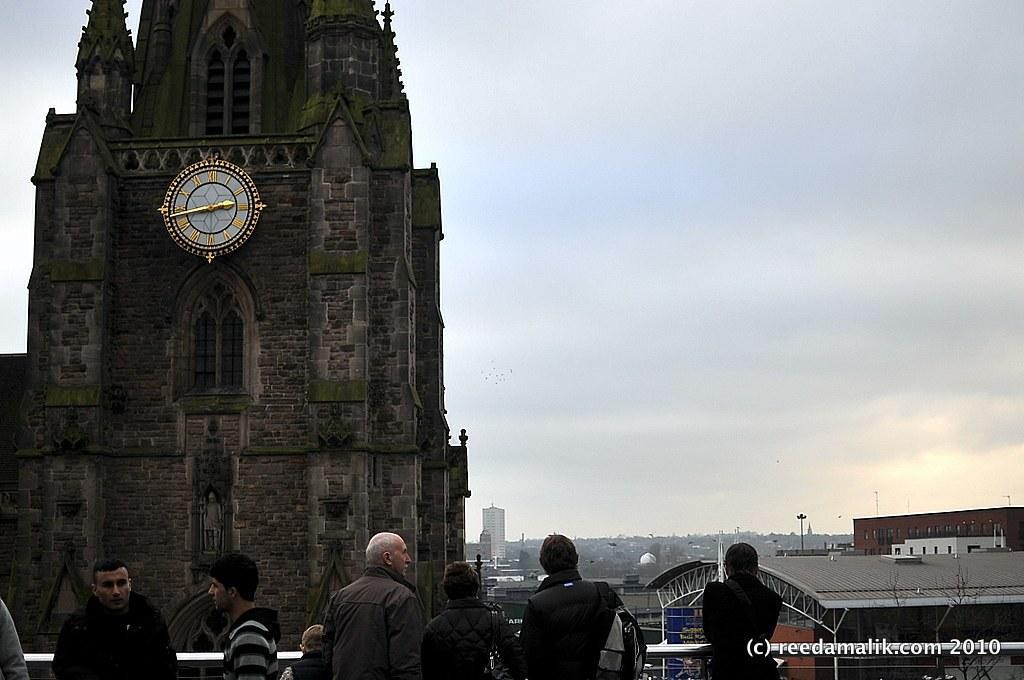Who or what can be seen in the image? There are people in the image. What type of structures are visible in the image? There are buildings in the image. Can you describe any specific objects in the image? There is a wall clock in the image. What else can be seen in the image? There are poles in the image. What is visible in the background of the image? The sky is visible in the image. Are there any words or letters in the image? Yes, there is text on the image. What type of knot can be seen in the image? There is no knot present in the image. What part of the image is made of a specific substance? It is not mentioned in the facts that any part of the image is made of a specific substance. 